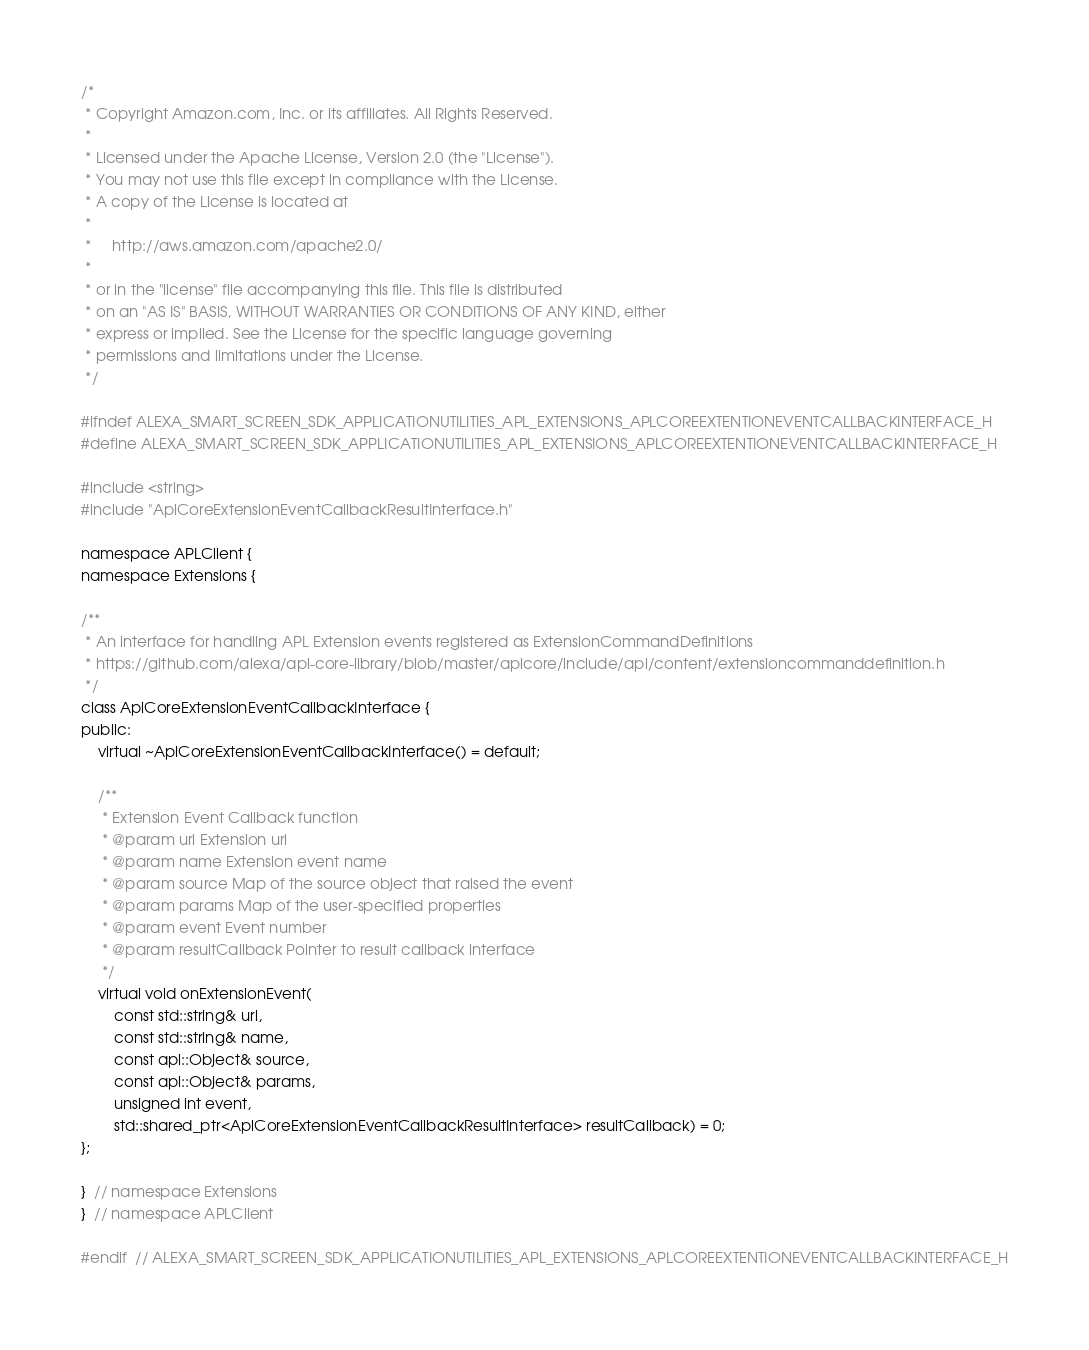Convert code to text. <code><loc_0><loc_0><loc_500><loc_500><_C_>/*
 * Copyright Amazon.com, Inc. or its affiliates. All Rights Reserved.
 *
 * Licensed under the Apache License, Version 2.0 (the "License").
 * You may not use this file except in compliance with the License.
 * A copy of the License is located at
 *
 *     http://aws.amazon.com/apache2.0/
 *
 * or in the "license" file accompanying this file. This file is distributed
 * on an "AS IS" BASIS, WITHOUT WARRANTIES OR CONDITIONS OF ANY KIND, either
 * express or implied. See the License for the specific language governing
 * permissions and limitations under the License.
 */

#ifndef ALEXA_SMART_SCREEN_SDK_APPLICATIONUTILITIES_APL_EXTENSIONS_APLCOREEXTENTIONEVENTCALLBACKINTERFACE_H
#define ALEXA_SMART_SCREEN_SDK_APPLICATIONUTILITIES_APL_EXTENSIONS_APLCOREEXTENTIONEVENTCALLBACKINTERFACE_H

#include <string>
#include "AplCoreExtensionEventCallbackResultInterface.h"

namespace APLClient {
namespace Extensions {

/**
 * An interface for handling APL Extension events registered as ExtensionCommandDefinitions
 * https://github.com/alexa/apl-core-library/blob/master/aplcore/include/apl/content/extensioncommanddefinition.h
 */
class AplCoreExtensionEventCallbackInterface {
public:
    virtual ~AplCoreExtensionEventCallbackInterface() = default;

    /**
     * Extension Event Callback function
     * @param uri Extension uri
     * @param name Extension event name
     * @param source Map of the source object that raised the event
     * @param params Map of the user-specified properties
     * @param event Event number
     * @param resultCallback Pointer to result callback interface
     */
    virtual void onExtensionEvent(
        const std::string& uri,
        const std::string& name,
        const apl::Object& source,
        const apl::Object& params,
        unsigned int event,
        std::shared_ptr<AplCoreExtensionEventCallbackResultInterface> resultCallback) = 0;
};

}  // namespace Extensions
}  // namespace APLClient

#endif  // ALEXA_SMART_SCREEN_SDK_APPLICATIONUTILITIES_APL_EXTENSIONS_APLCOREEXTENTIONEVENTCALLBACKINTERFACE_H
</code> 